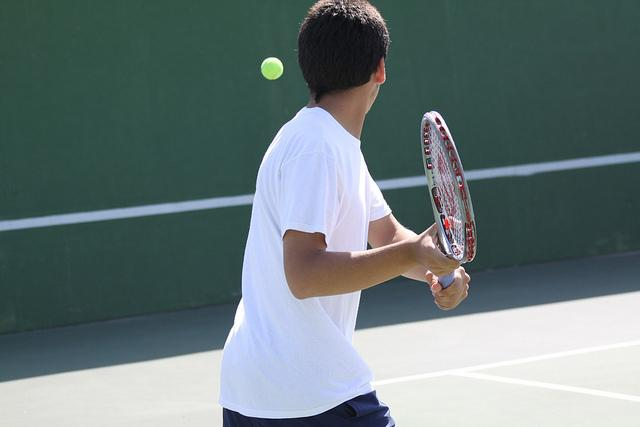What kind of strike is he preparing to do?

Choices:
A) lower hand
B) upper hand
C) backhand
D) forehand backhand 